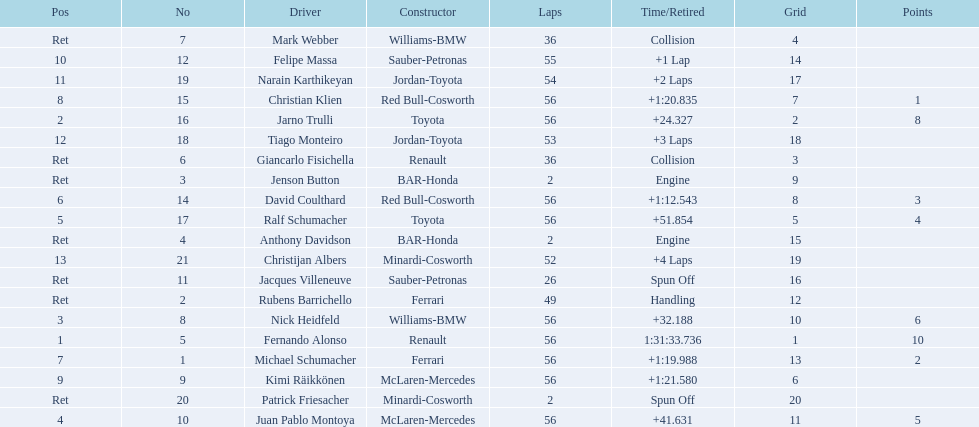Can you parse all the data within this table? {'header': ['Pos', 'No', 'Driver', 'Constructor', 'Laps', 'Time/Retired', 'Grid', 'Points'], 'rows': [['Ret', '7', 'Mark Webber', 'Williams-BMW', '36', 'Collision', '4', ''], ['10', '12', 'Felipe Massa', 'Sauber-Petronas', '55', '+1 Lap', '14', ''], ['11', '19', 'Narain Karthikeyan', 'Jordan-Toyota', '54', '+2 Laps', '17', ''], ['8', '15', 'Christian Klien', 'Red Bull-Cosworth', '56', '+1:20.835', '7', '1'], ['2', '16', 'Jarno Trulli', 'Toyota', '56', '+24.327', '2', '8'], ['12', '18', 'Tiago Monteiro', 'Jordan-Toyota', '53', '+3 Laps', '18', ''], ['Ret', '6', 'Giancarlo Fisichella', 'Renault', '36', 'Collision', '3', ''], ['Ret', '3', 'Jenson Button', 'BAR-Honda', '2', 'Engine', '9', ''], ['6', '14', 'David Coulthard', 'Red Bull-Cosworth', '56', '+1:12.543', '8', '3'], ['5', '17', 'Ralf Schumacher', 'Toyota', '56', '+51.854', '5', '4'], ['Ret', '4', 'Anthony Davidson', 'BAR-Honda', '2', 'Engine', '15', ''], ['13', '21', 'Christijan Albers', 'Minardi-Cosworth', '52', '+4 Laps', '19', ''], ['Ret', '11', 'Jacques Villeneuve', 'Sauber-Petronas', '26', 'Spun Off', '16', ''], ['Ret', '2', 'Rubens Barrichello', 'Ferrari', '49', 'Handling', '12', ''], ['3', '8', 'Nick Heidfeld', 'Williams-BMW', '56', '+32.188', '10', '6'], ['1', '5', 'Fernando Alonso', 'Renault', '56', '1:31:33.736', '1', '10'], ['7', '1', 'Michael Schumacher', 'Ferrari', '56', '+1:19.988', '13', '2'], ['9', '9', 'Kimi Räikkönen', 'McLaren-Mercedes', '56', '+1:21.580', '6', ''], ['Ret', '20', 'Patrick Friesacher', 'Minardi-Cosworth', '2', 'Spun Off', '20', ''], ['4', '10', 'Juan Pablo Montoya', 'McLaren-Mercedes', '56', '+41.631', '11', '5']]} What driver finished first? Fernando Alonso. 